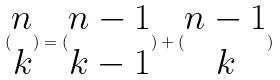<formula> <loc_0><loc_0><loc_500><loc_500>( \begin{matrix} n \\ k \end{matrix} ) = ( \begin{matrix} n - 1 \\ k - 1 \end{matrix} ) + ( \begin{matrix} n - 1 \\ k \end{matrix} )</formula> 